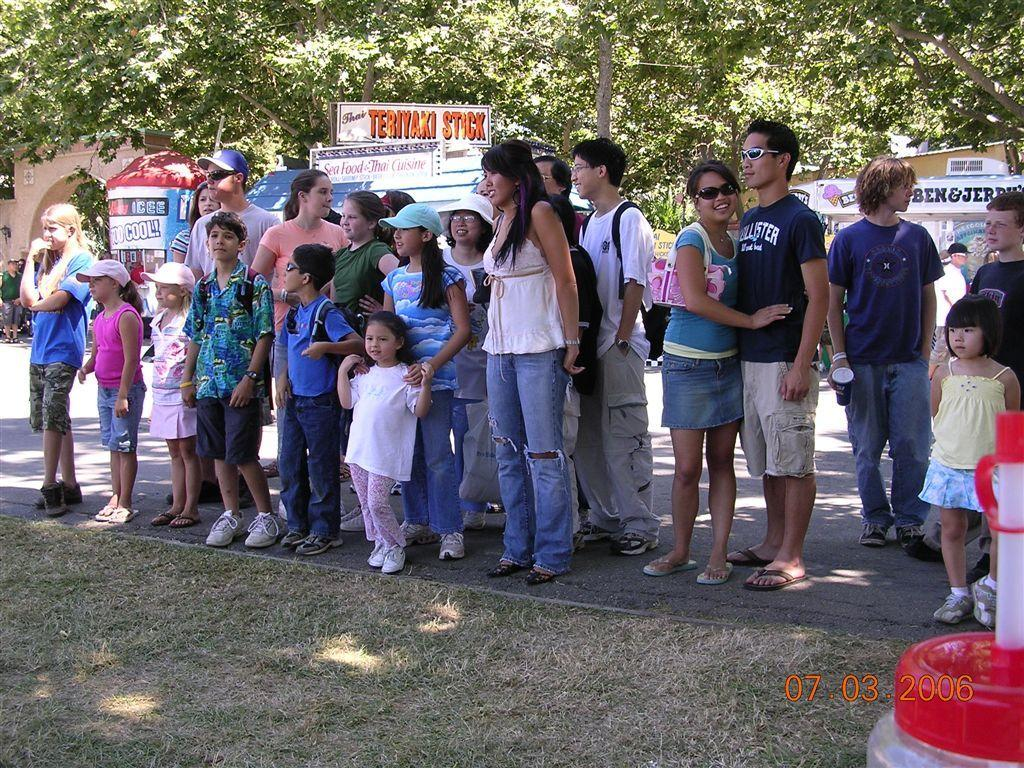How many people are in the image? There is a group of people in the image, but the exact number cannot be determined from the provided facts. Where are the people located in the image? The people are standing on the road in the image. What is on the surface in front of the people? There is grass on the surface in front of the people. What can be seen in the background of the image? There are trees and food stalls in the background of the image. Can you describe the kitten's treatment in the image? There is no kitten present in the image, so there is no treatment to describe. 